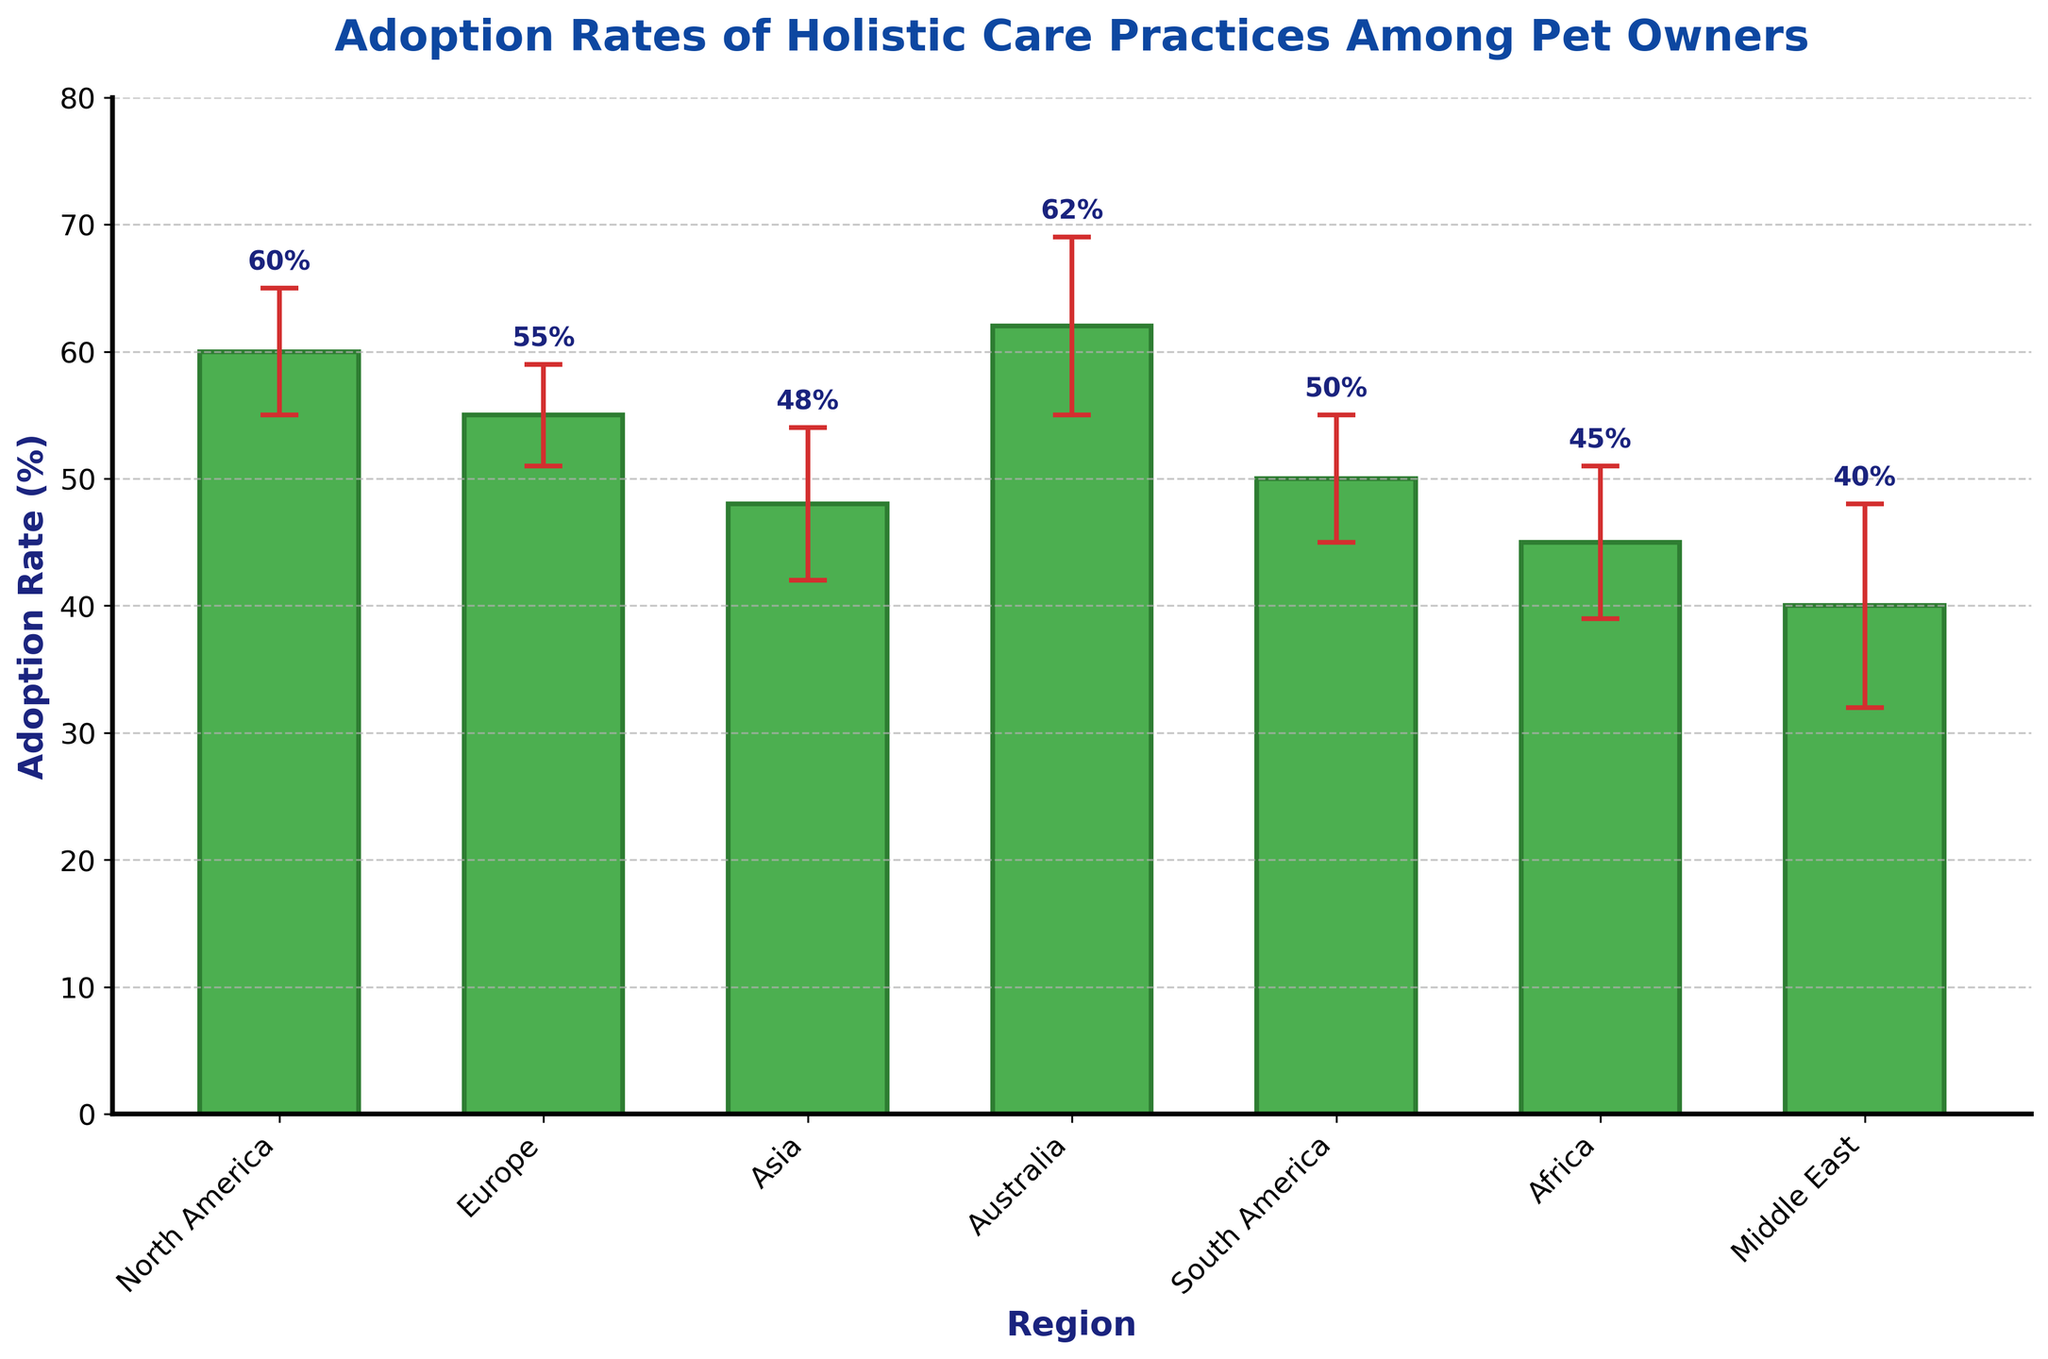What's the title of the chart? The title of the chart is displayed prominently at the top, showcasing the main subject of the visualization.
Answer: Adoption Rates of Holistic Care Practices Among Pet Owners Which region has the highest adoption rate? By observing the bars, we can identify the tallest bar, which indicates the highest adoption rate.
Answer: Australia What's the lowest adoption rate shown in the chart, and which region does it belong to? Find the shortest bar to determine the lowest adoption rate and then check the region label beneath it.
Answer: 40%, Middle East How much higher is the adoption rate in North America compared to Africa? Subtract Africa's adoption rate from North America's rate to get the difference. North America (60%) - Africa (45%) = 15%.
Answer: 15% What's the average adoption rate across all regions? Sum all the adoption rates and divide by the number of regions: (60 + 55 + 48 + 62 + 50 + 45 + 40) / 7 = 51.43%.
Answer: 51.43% Which two regions have the closest adoption rates? Compare the adoption rates, and find the pair of regions with the smallest difference between their rates. Europe (55%) and South America (50%) have a difference of 5% whereas others differ by more.
Answer: Europe and South America Between which two regions is the adoption rate difference largest? Evaluate the differences between adoption rates of all pairs and identify the pair where this difference is the greatest. North America (60%) and the Middle East (40%) have the largest difference, 20%.
Answer: North America and Middle East What are the error margins for South America and Australia, and how do they compare? Identify the error values for South America (5) and Australia (7) and compare them directly. Australia has a higher error margin (7 > 5).
Answer: South America's error is 5 and Australia's error is 7, and Australia’s error is higher What is the sum of the adoption rates for Europe and Asia? Add Europe’s adoption rate to Asia’s rate: 55% + 48% = 103%.
Answer: 103% How does the adoption rate in Africa compare to Asia? By direct comparison, Africa’s adoption rate (45%) is less than Asia’s (48%).
Answer: Africa has a lower adoption rate than Asia 